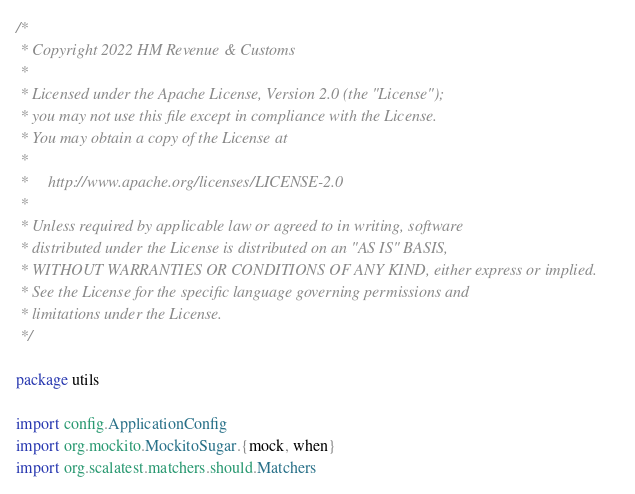Convert code to text. <code><loc_0><loc_0><loc_500><loc_500><_Scala_>/*
 * Copyright 2022 HM Revenue & Customs
 *
 * Licensed under the Apache License, Version 2.0 (the "License");
 * you may not use this file except in compliance with the License.
 * You may obtain a copy of the License at
 *
 *     http://www.apache.org/licenses/LICENSE-2.0
 *
 * Unless required by applicable law or agreed to in writing, software
 * distributed under the License is distributed on an "AS IS" BASIS,
 * WITHOUT WARRANTIES OR CONDITIONS OF ANY KIND, either express or implied.
 * See the License for the specific language governing permissions and
 * limitations under the License.
 */

package utils

import config.ApplicationConfig
import org.mockito.MockitoSugar.{mock, when}
import org.scalatest.matchers.should.Matchers</code> 